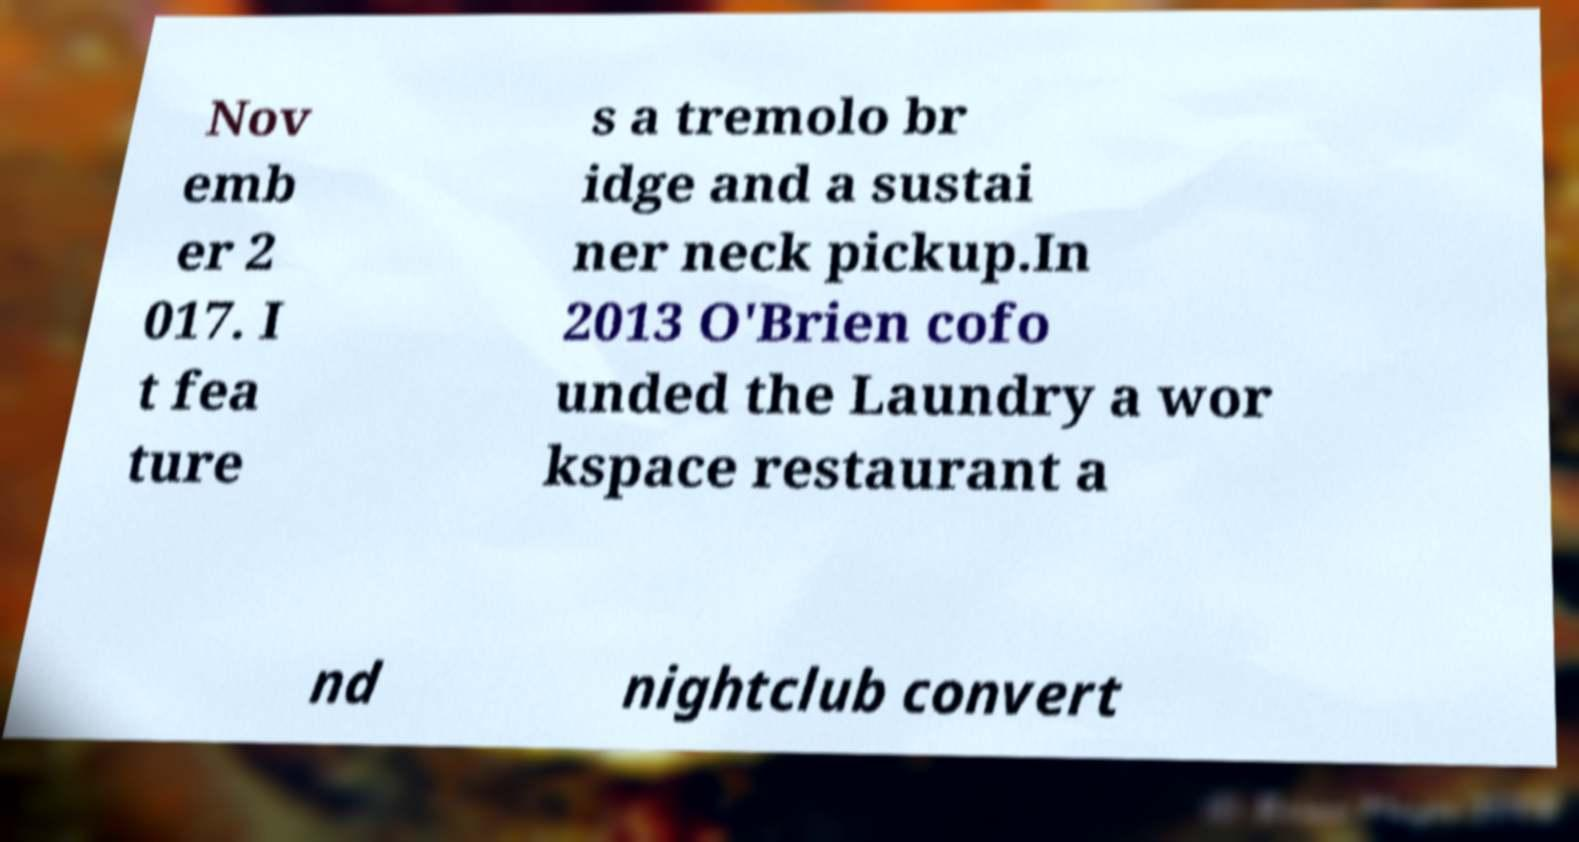Please identify and transcribe the text found in this image. Nov emb er 2 017. I t fea ture s a tremolo br idge and a sustai ner neck pickup.In 2013 O'Brien cofo unded the Laundry a wor kspace restaurant a nd nightclub convert 